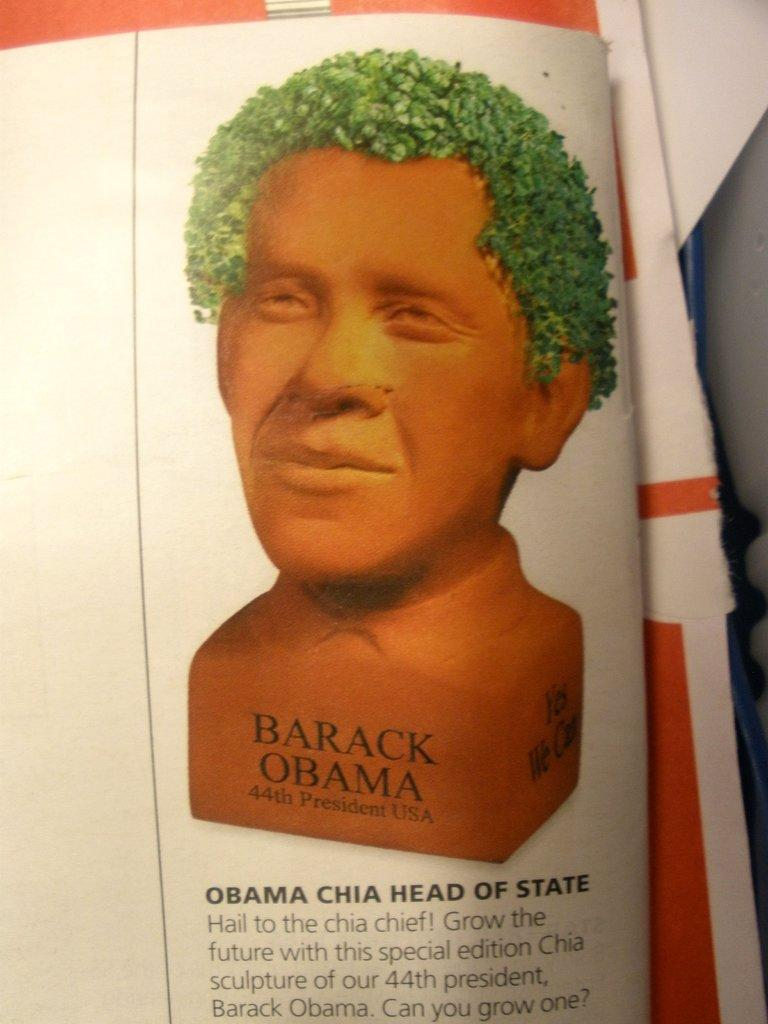What is the main subject of the image? There is a statue in the image. What does the statue represent? The statue is of a person's face. What is the color of the statue? The statue is brown in color. What else can be seen in the image besides the statue? There is a white paper with something written on it in the image. What type of jelly can be seen dripping from the statue's face in the image? There is no jelly present in the image, and the statue's face is not depicted as dripping anything. 